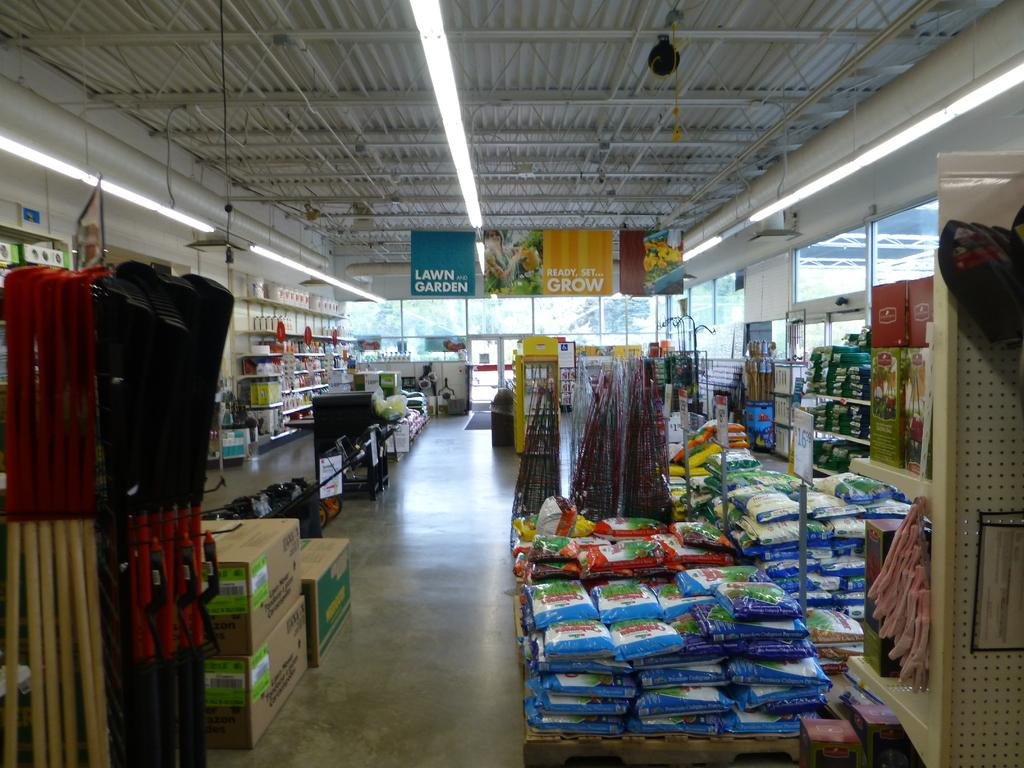<image>
Share a concise interpretation of the image provided. Empty store with a banner that says Ready, set, grow. 